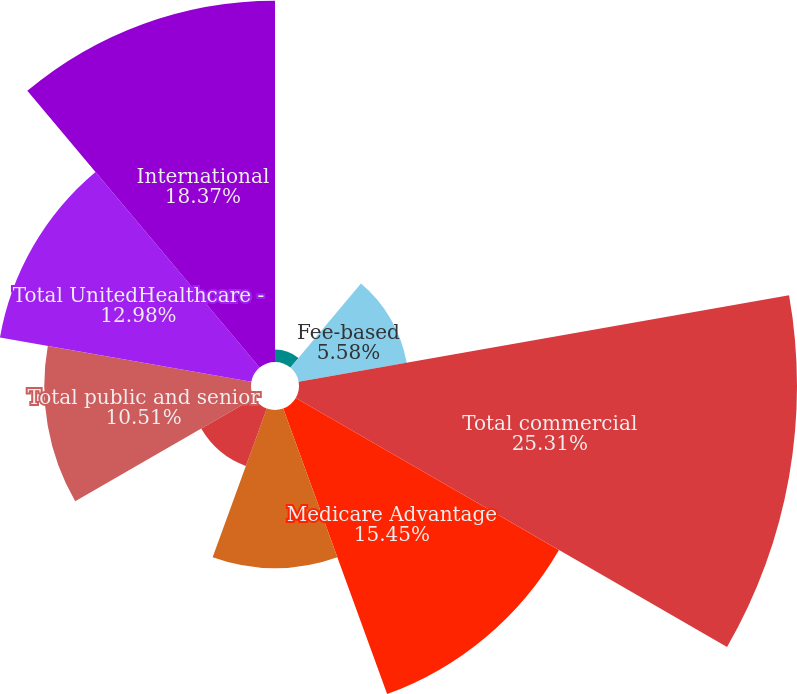Convert chart to OTSL. <chart><loc_0><loc_0><loc_500><loc_500><pie_chart><fcel>Risk-based<fcel>Fee-based<fcel>Total commercial<fcel>Medicare Advantage<fcel>Medicaid<fcel>Medicare Supplement<fcel>Total public and senior<fcel>Total UnitedHealthcare -<fcel>International<nl><fcel>0.64%<fcel>5.58%<fcel>25.32%<fcel>15.45%<fcel>8.05%<fcel>3.11%<fcel>10.51%<fcel>12.98%<fcel>18.37%<nl></chart> 